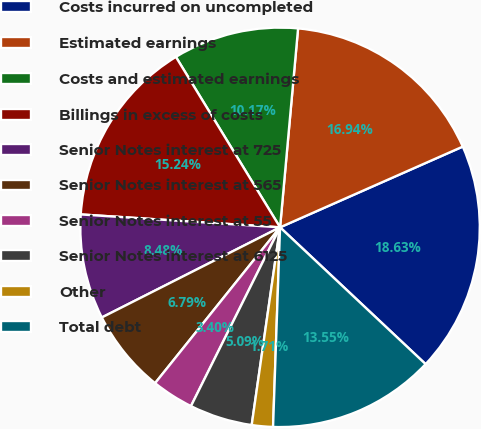<chart> <loc_0><loc_0><loc_500><loc_500><pie_chart><fcel>Costs incurred on uncompleted<fcel>Estimated earnings<fcel>Costs and estimated earnings<fcel>Billings in excess of costs<fcel>Senior Notes interest at 725<fcel>Senior Notes interest at 565<fcel>Senior Notes interest at 55<fcel>Senior Notes interest at 6125<fcel>Other<fcel>Total debt<nl><fcel>18.63%<fcel>16.94%<fcel>10.17%<fcel>15.24%<fcel>8.48%<fcel>6.79%<fcel>3.4%<fcel>5.09%<fcel>1.71%<fcel>13.55%<nl></chart> 